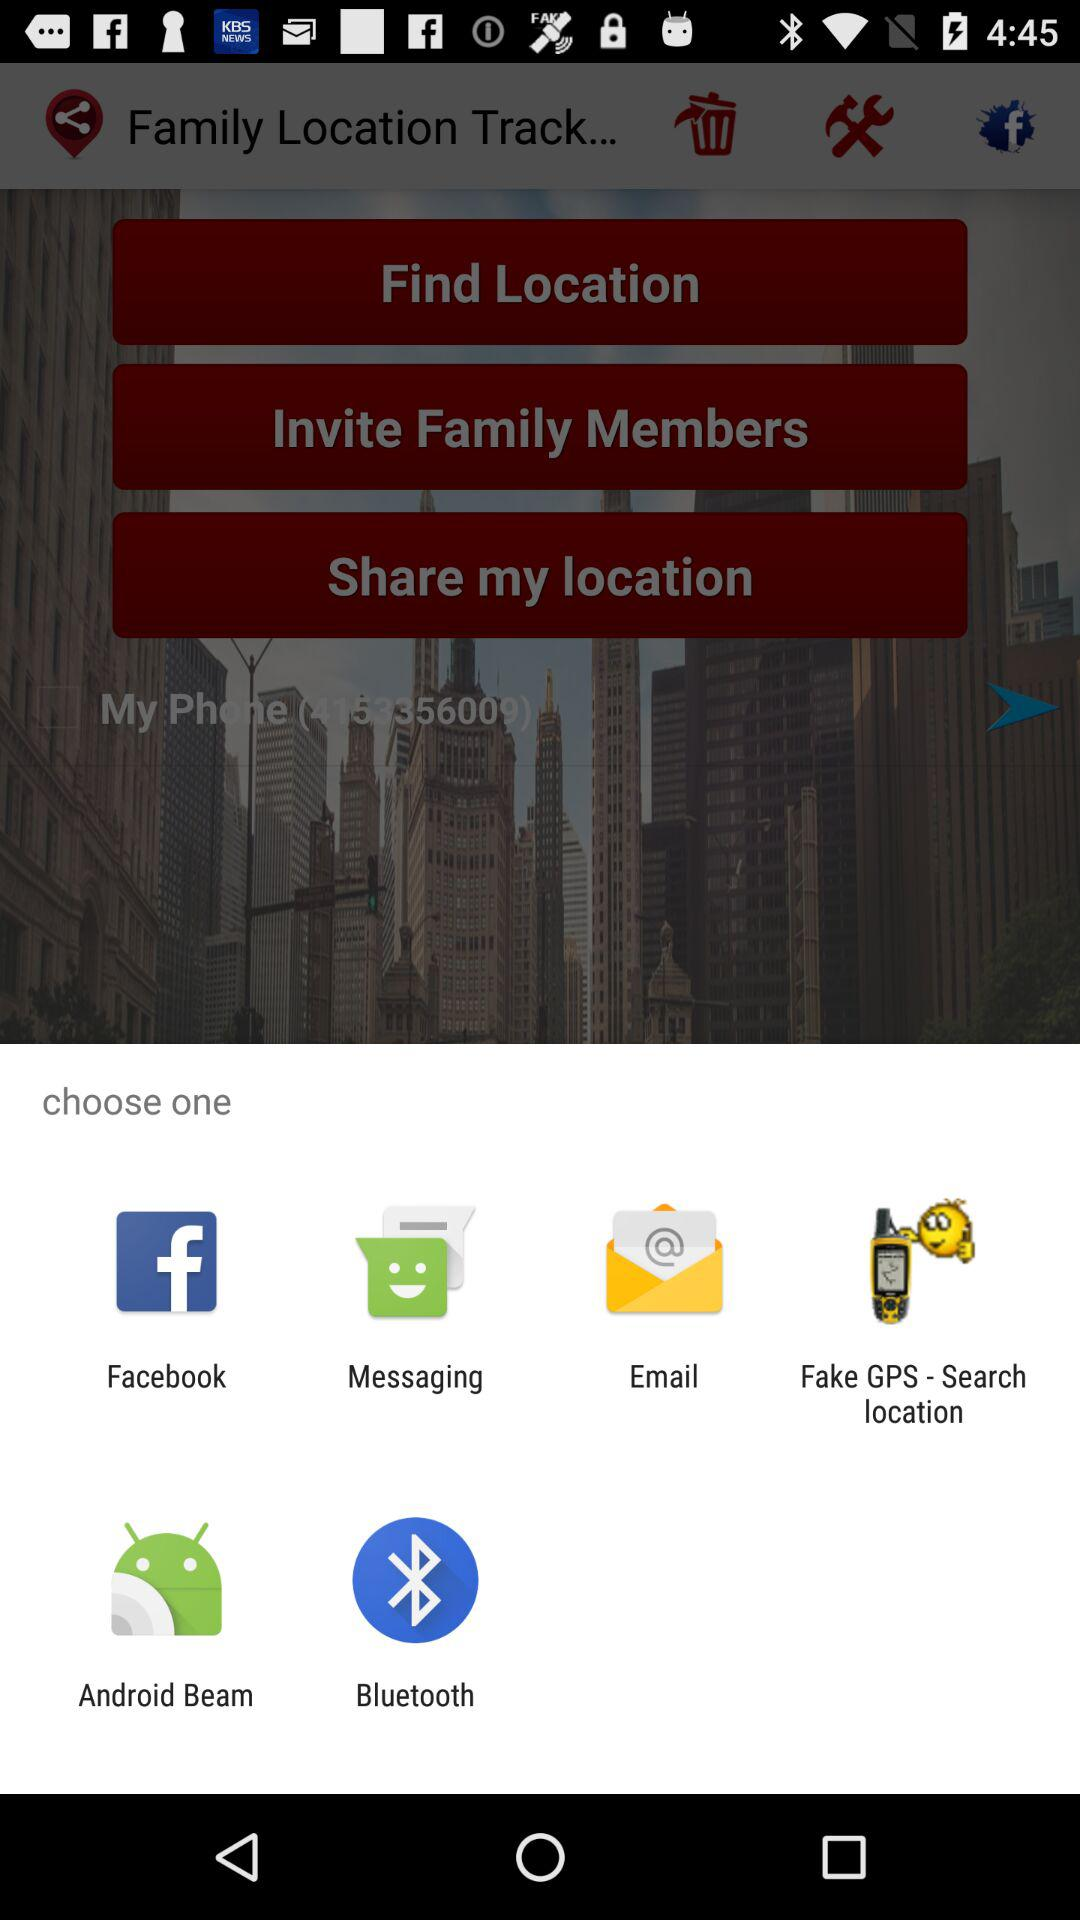Which option is selected?
When the provided information is insufficient, respond with <no answer>. <no answer> 